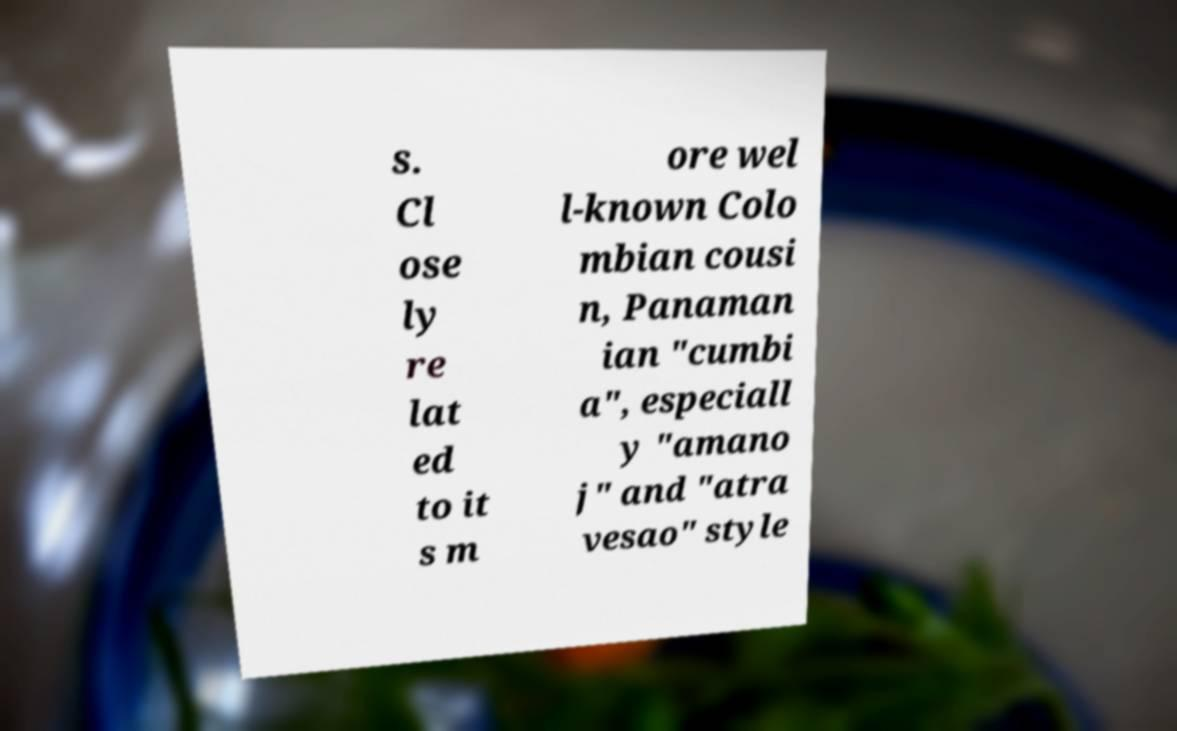Can you read and provide the text displayed in the image?This photo seems to have some interesting text. Can you extract and type it out for me? s. Cl ose ly re lat ed to it s m ore wel l-known Colo mbian cousi n, Panaman ian "cumbi a", especiall y "amano j" and "atra vesao" style 